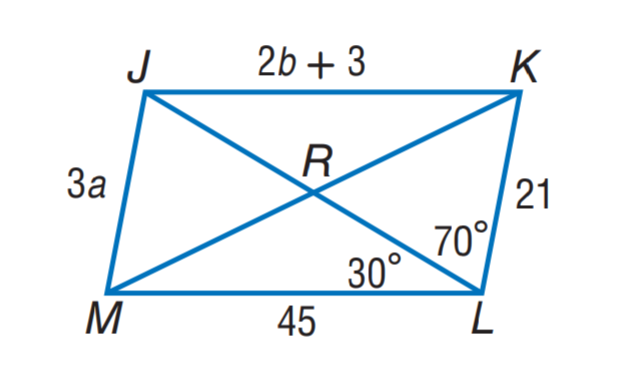Answer the mathemtical geometry problem and directly provide the correct option letter.
Question: Use parallelogram J K L M to find m \angle M J K.
Choices: A: 80 B: 100 C: 110 D: 120 B 